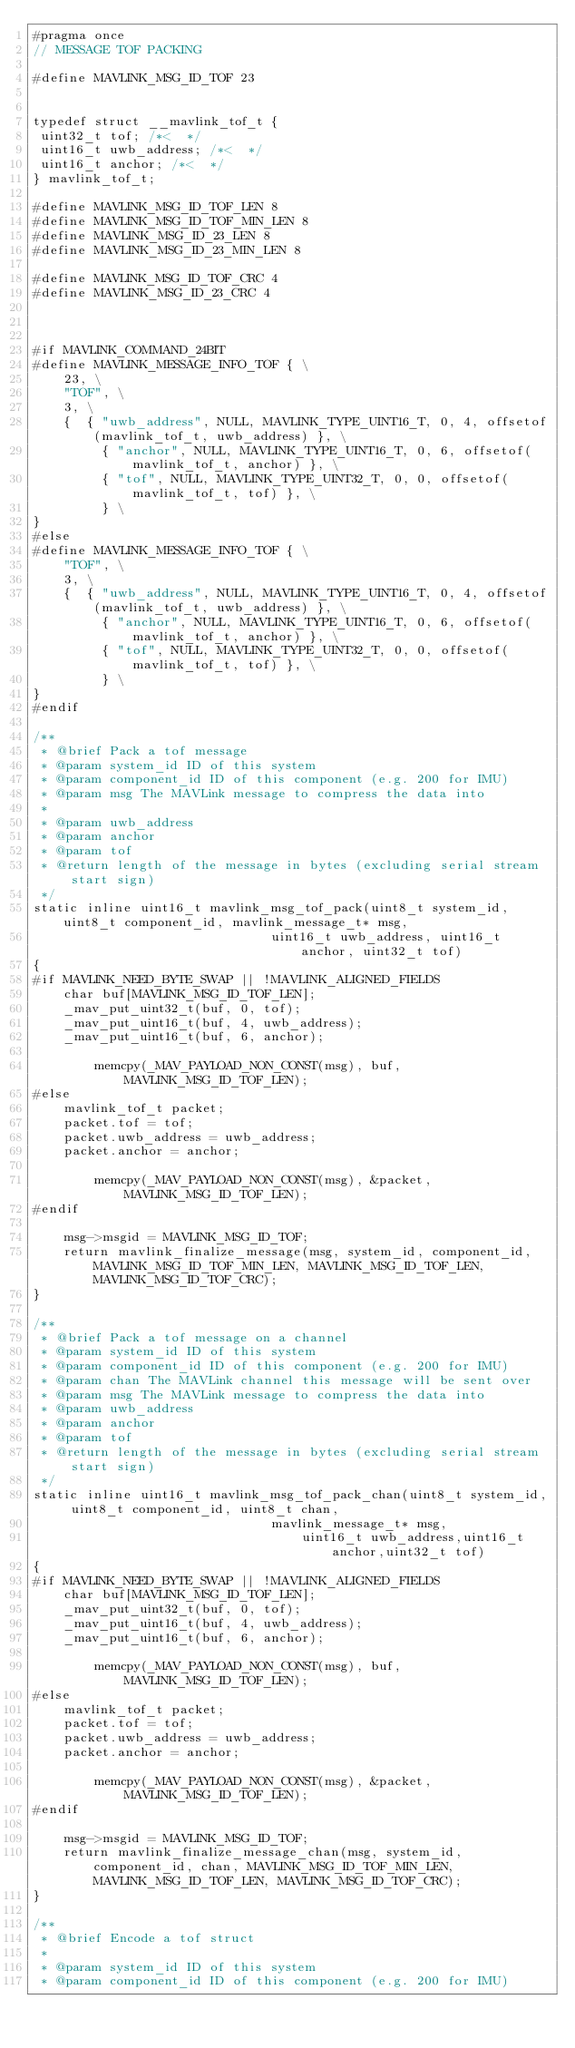Convert code to text. <code><loc_0><loc_0><loc_500><loc_500><_C_>#pragma once
// MESSAGE TOF PACKING

#define MAVLINK_MSG_ID_TOF 23


typedef struct __mavlink_tof_t {
 uint32_t tof; /*<  */
 uint16_t uwb_address; /*<  */
 uint16_t anchor; /*<  */
} mavlink_tof_t;

#define MAVLINK_MSG_ID_TOF_LEN 8
#define MAVLINK_MSG_ID_TOF_MIN_LEN 8
#define MAVLINK_MSG_ID_23_LEN 8
#define MAVLINK_MSG_ID_23_MIN_LEN 8

#define MAVLINK_MSG_ID_TOF_CRC 4
#define MAVLINK_MSG_ID_23_CRC 4



#if MAVLINK_COMMAND_24BIT
#define MAVLINK_MESSAGE_INFO_TOF { \
    23, \
    "TOF", \
    3, \
    {  { "uwb_address", NULL, MAVLINK_TYPE_UINT16_T, 0, 4, offsetof(mavlink_tof_t, uwb_address) }, \
         { "anchor", NULL, MAVLINK_TYPE_UINT16_T, 0, 6, offsetof(mavlink_tof_t, anchor) }, \
         { "tof", NULL, MAVLINK_TYPE_UINT32_T, 0, 0, offsetof(mavlink_tof_t, tof) }, \
         } \
}
#else
#define MAVLINK_MESSAGE_INFO_TOF { \
    "TOF", \
    3, \
    {  { "uwb_address", NULL, MAVLINK_TYPE_UINT16_T, 0, 4, offsetof(mavlink_tof_t, uwb_address) }, \
         { "anchor", NULL, MAVLINK_TYPE_UINT16_T, 0, 6, offsetof(mavlink_tof_t, anchor) }, \
         { "tof", NULL, MAVLINK_TYPE_UINT32_T, 0, 0, offsetof(mavlink_tof_t, tof) }, \
         } \
}
#endif

/**
 * @brief Pack a tof message
 * @param system_id ID of this system
 * @param component_id ID of this component (e.g. 200 for IMU)
 * @param msg The MAVLink message to compress the data into
 *
 * @param uwb_address  
 * @param anchor  
 * @param tof  
 * @return length of the message in bytes (excluding serial stream start sign)
 */
static inline uint16_t mavlink_msg_tof_pack(uint8_t system_id, uint8_t component_id, mavlink_message_t* msg,
                               uint16_t uwb_address, uint16_t anchor, uint32_t tof)
{
#if MAVLINK_NEED_BYTE_SWAP || !MAVLINK_ALIGNED_FIELDS
    char buf[MAVLINK_MSG_ID_TOF_LEN];
    _mav_put_uint32_t(buf, 0, tof);
    _mav_put_uint16_t(buf, 4, uwb_address);
    _mav_put_uint16_t(buf, 6, anchor);

        memcpy(_MAV_PAYLOAD_NON_CONST(msg), buf, MAVLINK_MSG_ID_TOF_LEN);
#else
    mavlink_tof_t packet;
    packet.tof = tof;
    packet.uwb_address = uwb_address;
    packet.anchor = anchor;

        memcpy(_MAV_PAYLOAD_NON_CONST(msg), &packet, MAVLINK_MSG_ID_TOF_LEN);
#endif

    msg->msgid = MAVLINK_MSG_ID_TOF;
    return mavlink_finalize_message(msg, system_id, component_id, MAVLINK_MSG_ID_TOF_MIN_LEN, MAVLINK_MSG_ID_TOF_LEN, MAVLINK_MSG_ID_TOF_CRC);
}

/**
 * @brief Pack a tof message on a channel
 * @param system_id ID of this system
 * @param component_id ID of this component (e.g. 200 for IMU)
 * @param chan The MAVLink channel this message will be sent over
 * @param msg The MAVLink message to compress the data into
 * @param uwb_address  
 * @param anchor  
 * @param tof  
 * @return length of the message in bytes (excluding serial stream start sign)
 */
static inline uint16_t mavlink_msg_tof_pack_chan(uint8_t system_id, uint8_t component_id, uint8_t chan,
                               mavlink_message_t* msg,
                                   uint16_t uwb_address,uint16_t anchor,uint32_t tof)
{
#if MAVLINK_NEED_BYTE_SWAP || !MAVLINK_ALIGNED_FIELDS
    char buf[MAVLINK_MSG_ID_TOF_LEN];
    _mav_put_uint32_t(buf, 0, tof);
    _mav_put_uint16_t(buf, 4, uwb_address);
    _mav_put_uint16_t(buf, 6, anchor);

        memcpy(_MAV_PAYLOAD_NON_CONST(msg), buf, MAVLINK_MSG_ID_TOF_LEN);
#else
    mavlink_tof_t packet;
    packet.tof = tof;
    packet.uwb_address = uwb_address;
    packet.anchor = anchor;

        memcpy(_MAV_PAYLOAD_NON_CONST(msg), &packet, MAVLINK_MSG_ID_TOF_LEN);
#endif

    msg->msgid = MAVLINK_MSG_ID_TOF;
    return mavlink_finalize_message_chan(msg, system_id, component_id, chan, MAVLINK_MSG_ID_TOF_MIN_LEN, MAVLINK_MSG_ID_TOF_LEN, MAVLINK_MSG_ID_TOF_CRC);
}

/**
 * @brief Encode a tof struct
 *
 * @param system_id ID of this system
 * @param component_id ID of this component (e.g. 200 for IMU)</code> 